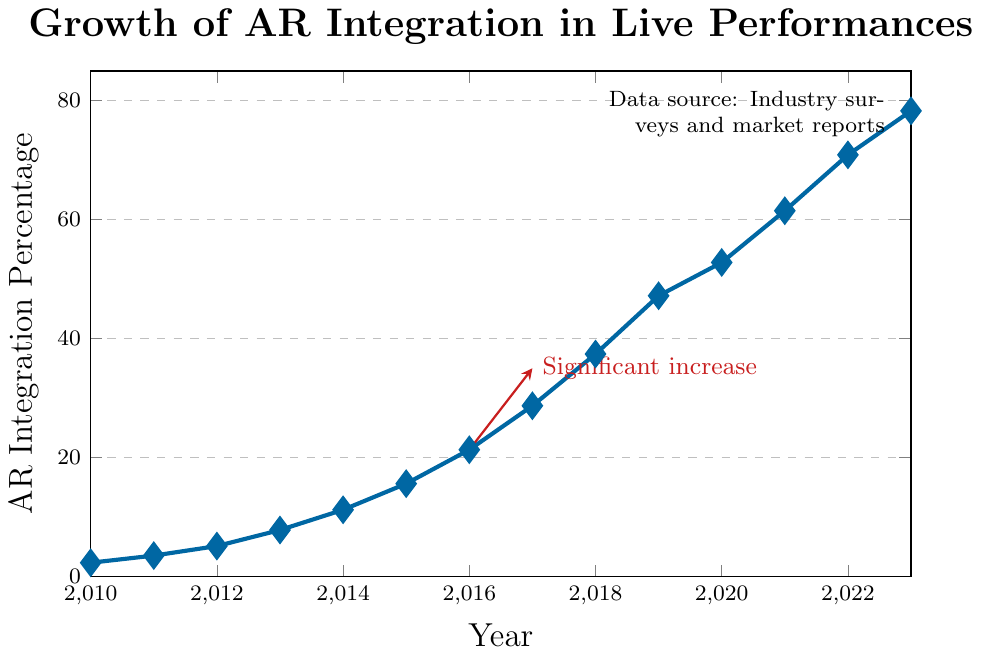What is the significant event marked on the plot? There is a thick red arrow on the plot pointing from 2016 to 2017 with a label indicating a "Significant increase". This visually highlights a notable rise in AR integration during this period.
Answer: Significant increase from 2016 to 2017 What is the AR integration percentage in 2023? Locate the data point for the year 2023 on the X-axis and check its corresponding Y-value, which represents the AR integration percentage.
Answer: 78.3% In which year did AR integration first exceed 20%? Scan the Y-axis for the 20% mark and identify the first year where the data point is above this mark. According to the plot, this happens in 2016.
Answer: 2016 How much did the AR integration percentage increase between 2014 and 2018? Find the data points for 2014 and 2018, then compute the difference: 37.4 - 11.2 = 26.2.
Answer: 26.2% Which year saw the largest percentage increase in AR integration? Examine the differences between consecutive years. The largest jump is from 2016 to 2017, going from 21.3% to 28.7%, an increase of 7.4%.
Answer: 2017 What is the average AR integration percentage between 2010 and 2023? Sum the AR integration percentages for all years from 2010 to 2023 and divide by the number of years: (2.3 + 3.5 + 5.1 + 7.8 + 11.2 + 15.6 + 21.3 + 28.7 + 37.4 + 47.2 + 52.8 + 61.5 + 70.9 + 78.3) / 14 ≈ 30.05.
Answer: 30.05% Compare the AR integration percentage in 2019 with 2020. Which year had a higher percentage and by how much? Locate the percentages for 2019 and 2020: 47.2% and 52.8%. Calculate the difference: 52.8% - 47.2% = 5.6%.
Answer: 2020 by 5.6% Describe the trend of AR integration from 2010 to 2023. The plot demonstrates a consistent upward trend in AR integration percentage from 2010 to 2023, starting at 2.3% in 2010 and reaching 78.3% in 2023, with notable accelerations around mid-decade.
Answer: Upward trend What was the AR integration percentage in the year exactly midway between 2010 and 2023? The midpoint between 2010 and 2023 is 2016. According to the plot, the AR integration percentage in 2016 is 21.3%.
Answer: 21.3% What was the AR integration percentage three years after 2015? Three years after 2015 is 2018. Check the plot for the year 2018 to find the AR integration percentage, which is 37.4%.
Answer: 37.4% 